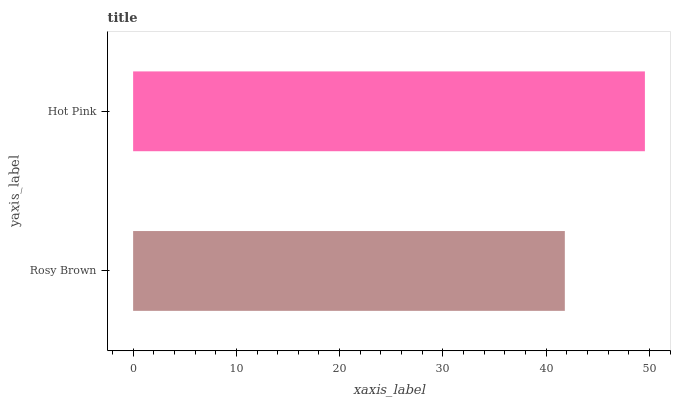Is Rosy Brown the minimum?
Answer yes or no. Yes. Is Hot Pink the maximum?
Answer yes or no. Yes. Is Hot Pink the minimum?
Answer yes or no. No. Is Hot Pink greater than Rosy Brown?
Answer yes or no. Yes. Is Rosy Brown less than Hot Pink?
Answer yes or no. Yes. Is Rosy Brown greater than Hot Pink?
Answer yes or no. No. Is Hot Pink less than Rosy Brown?
Answer yes or no. No. Is Hot Pink the high median?
Answer yes or no. Yes. Is Rosy Brown the low median?
Answer yes or no. Yes. Is Rosy Brown the high median?
Answer yes or no. No. Is Hot Pink the low median?
Answer yes or no. No. 